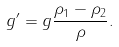<formula> <loc_0><loc_0><loc_500><loc_500>g ^ { \prime } = g { \frac { \rho _ { 1 } - \rho _ { 2 } } { \rho } } .</formula> 